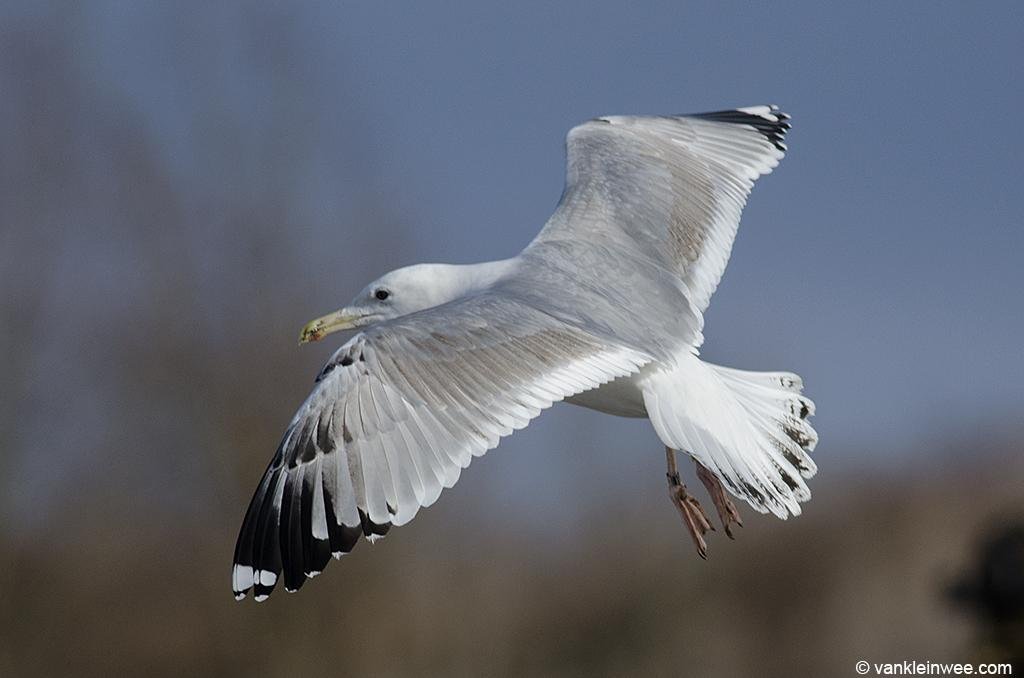What type of animal is present in the image? There is a bird in the image. Can you describe the color pattern of the bird? The bird is white and black in color. What is the purpose of the bird in the image? The bird is a watermark. How would you describe the background of the image? The background of the image is blurred. What type of food is the bird holding in the image? There is no food present in the image, and the bird is not holding anything. 